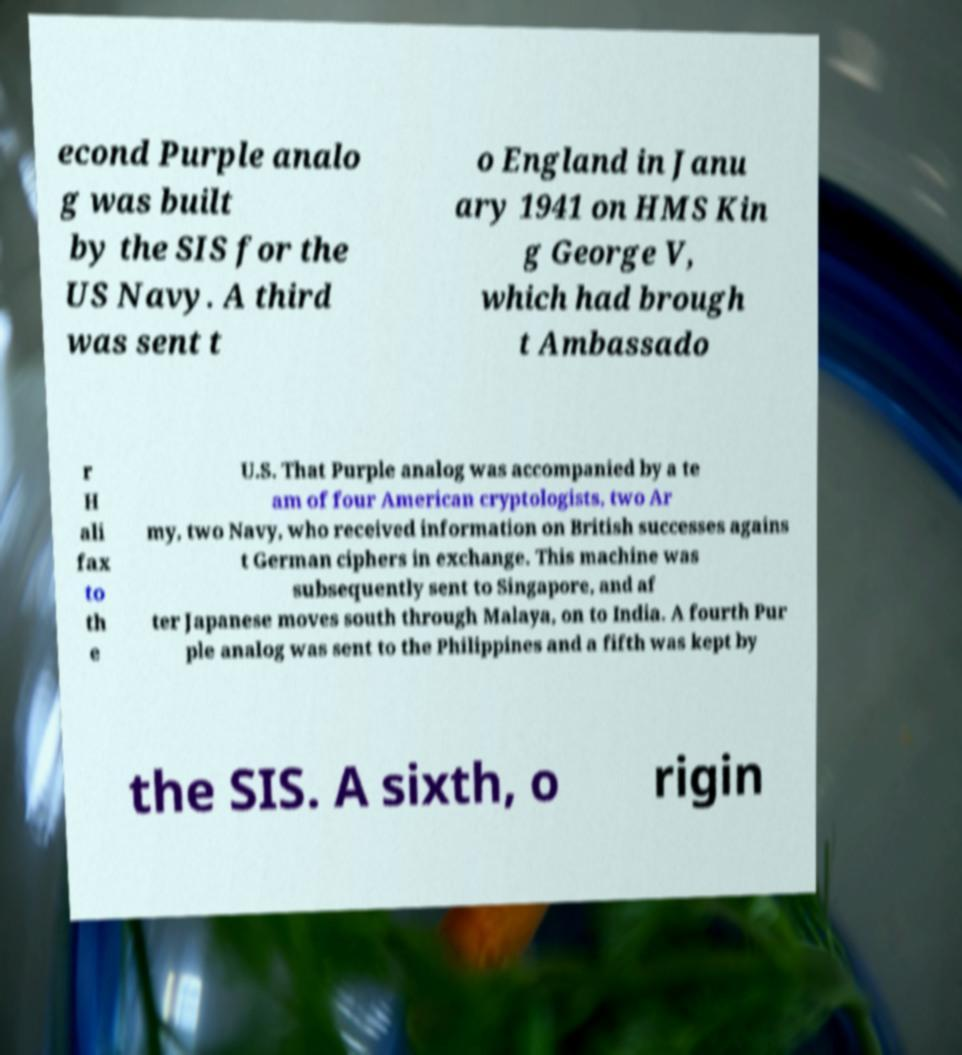What messages or text are displayed in this image? I need them in a readable, typed format. econd Purple analo g was built by the SIS for the US Navy. A third was sent t o England in Janu ary 1941 on HMS Kin g George V, which had brough t Ambassado r H ali fax to th e U.S. That Purple analog was accompanied by a te am of four American cryptologists, two Ar my, two Navy, who received information on British successes agains t German ciphers in exchange. This machine was subsequently sent to Singapore, and af ter Japanese moves south through Malaya, on to India. A fourth Pur ple analog was sent to the Philippines and a fifth was kept by the SIS. A sixth, o rigin 